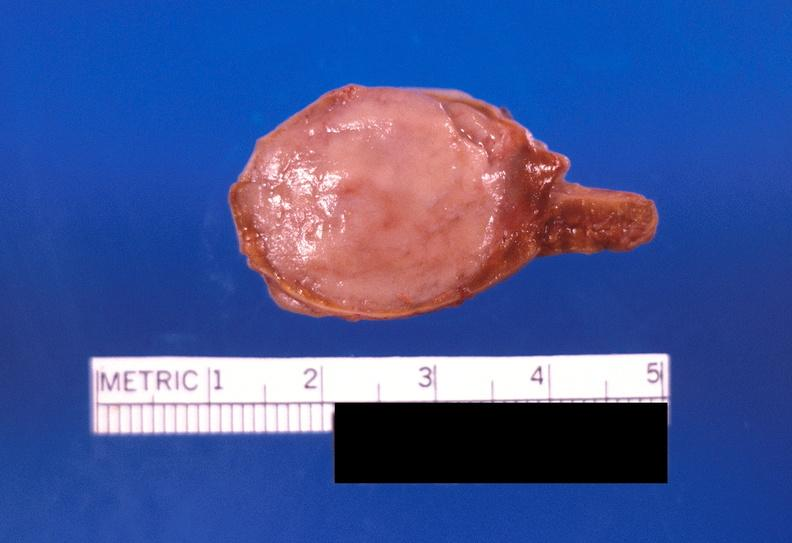where does this belong to?
Answer the question using a single word or phrase. Endocrine system 